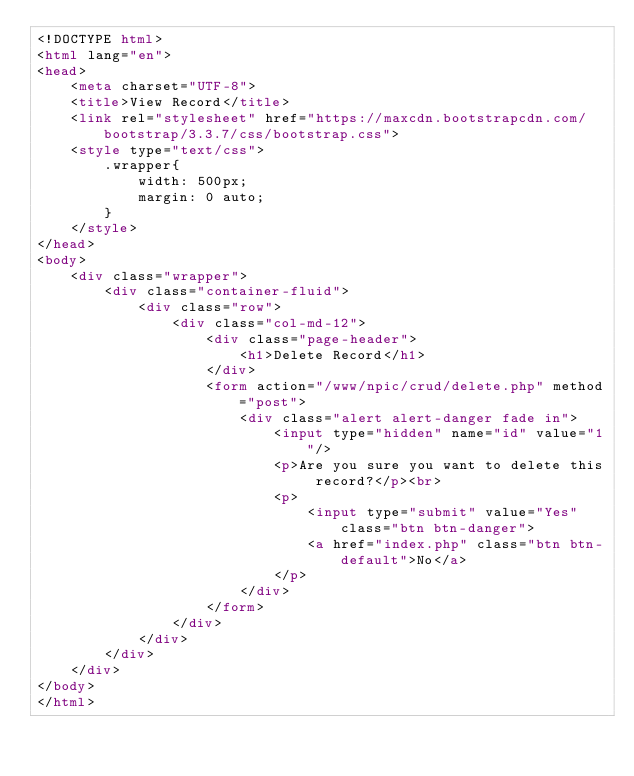Convert code to text. <code><loc_0><loc_0><loc_500><loc_500><_HTML_><!DOCTYPE html>
<html lang="en">
<head>
    <meta charset="UTF-8">
    <title>View Record</title>
    <link rel="stylesheet" href="https://maxcdn.bootstrapcdn.com/bootstrap/3.3.7/css/bootstrap.css">
    <style type="text/css">
        .wrapper{
            width: 500px;
            margin: 0 auto;
        }
    </style>
</head>
<body>
    <div class="wrapper">
        <div class="container-fluid">
            <div class="row">
                <div class="col-md-12">
                    <div class="page-header">
                        <h1>Delete Record</h1>
                    </div>
                    <form action="/www/npic/crud/delete.php" method="post">
                        <div class="alert alert-danger fade in">
                            <input type="hidden" name="id" value="1"/>
                            <p>Are you sure you want to delete this record?</p><br>
                            <p>
                                <input type="submit" value="Yes" class="btn btn-danger">
                                <a href="index.php" class="btn btn-default">No</a>
                            </p>
                        </div>
                    </form>
                </div>
            </div>        
        </div>
    </div>
</body>
</html></code> 